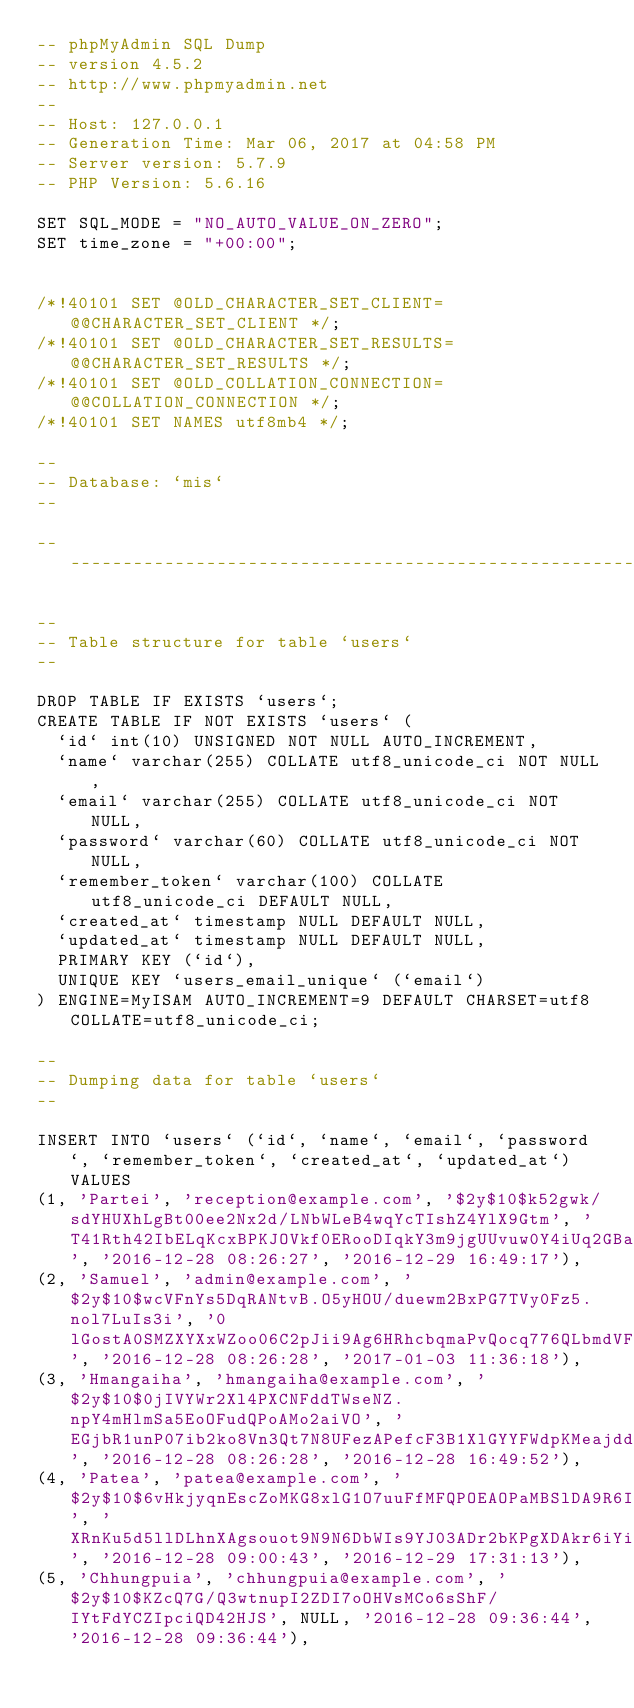Convert code to text. <code><loc_0><loc_0><loc_500><loc_500><_SQL_>-- phpMyAdmin SQL Dump
-- version 4.5.2
-- http://www.phpmyadmin.net
--
-- Host: 127.0.0.1
-- Generation Time: Mar 06, 2017 at 04:58 PM
-- Server version: 5.7.9
-- PHP Version: 5.6.16

SET SQL_MODE = "NO_AUTO_VALUE_ON_ZERO";
SET time_zone = "+00:00";


/*!40101 SET @OLD_CHARACTER_SET_CLIENT=@@CHARACTER_SET_CLIENT */;
/*!40101 SET @OLD_CHARACTER_SET_RESULTS=@@CHARACTER_SET_RESULTS */;
/*!40101 SET @OLD_COLLATION_CONNECTION=@@COLLATION_CONNECTION */;
/*!40101 SET NAMES utf8mb4 */;

--
-- Database: `mis`
--

-- --------------------------------------------------------

--
-- Table structure for table `users`
--

DROP TABLE IF EXISTS `users`;
CREATE TABLE IF NOT EXISTS `users` (
  `id` int(10) UNSIGNED NOT NULL AUTO_INCREMENT,
  `name` varchar(255) COLLATE utf8_unicode_ci NOT NULL,
  `email` varchar(255) COLLATE utf8_unicode_ci NOT NULL,
  `password` varchar(60) COLLATE utf8_unicode_ci NOT NULL,
  `remember_token` varchar(100) COLLATE utf8_unicode_ci DEFAULT NULL,
  `created_at` timestamp NULL DEFAULT NULL,
  `updated_at` timestamp NULL DEFAULT NULL,
  PRIMARY KEY (`id`),
  UNIQUE KEY `users_email_unique` (`email`)
) ENGINE=MyISAM AUTO_INCREMENT=9 DEFAULT CHARSET=utf8 COLLATE=utf8_unicode_ci;

--
-- Dumping data for table `users`
--

INSERT INTO `users` (`id`, `name`, `email`, `password`, `remember_token`, `created_at`, `updated_at`) VALUES
(1, 'Partei', 'reception@example.com', '$2y$10$k52gwk/sdYHUXhLgBt00ee2Nx2d/LNbWLeB4wqYcTIshZ4YlX9Gtm', 'T41Rth42IbELqKcxBPKJOVkf0ERooDIqkY3m9jgUUvuw0Y4iUq2GBaTQCBOj', '2016-12-28 08:26:27', '2016-12-29 16:49:17'),
(2, 'Samuel', 'admin@example.com', '$2y$10$wcVFnYs5DqRANtvB.O5yHOU/duewm2BxPG7TVy0Fz5.nol7LuIs3i', '0lGostA0SMZXYXxWZoo06C2pJii9Ag6HRhcbqmaPvQocq776QLbmdVF4g51M', '2016-12-28 08:26:28', '2017-01-03 11:36:18'),
(3, 'Hmangaiha', 'hmangaiha@example.com', '$2y$10$0jIVYWr2Xl4PXCNFddTWseNZ.npY4mHlmSa5EoOFudQPoAMo2aiVO', 'EGjbR1unP07ib2ko8Vn3Qt7N8UFezAPefcF3B1XlGYYFWdpKMeajddNnn5ND', '2016-12-28 08:26:28', '2016-12-28 16:49:52'),
(4, 'Patea', 'patea@example.com', '$2y$10$6vHkjyqnEscZoMKG8xlG1O7uuFfMFQPOEAOPaMBSlDA9R6IDvOnGe', 'XRnKu5d5llDLhnXAgsouot9N9N6DbWIs9YJ03ADr2bKPgXDAkr6iYiI8EGOf', '2016-12-28 09:00:43', '2016-12-29 17:31:13'),
(5, 'Chhungpuia', 'chhungpuia@example.com', '$2y$10$KZcQ7G/Q3wtnupI2ZDI7oOHVsMCo6sShF/IYtFdYCZIpciQD42HJS', NULL, '2016-12-28 09:36:44', '2016-12-28 09:36:44'),</code> 